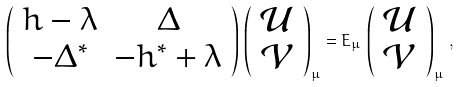Convert formula to latex. <formula><loc_0><loc_0><loc_500><loc_500>\left ( \begin{array} { c c } h - \lambda & \Delta \\ - \Delta ^ { \ast } & - h ^ { \ast } + \lambda \end{array} \right ) \, \left ( \begin{array} { c } \mathcal { U } \\ \mathcal { V } \end{array} \right ) _ { \mu } = E _ { \mu } \, \left ( \begin{array} { c } \mathcal { U } \\ \mathcal { V } \end{array} \right ) _ { \mu } \, ,</formula> 